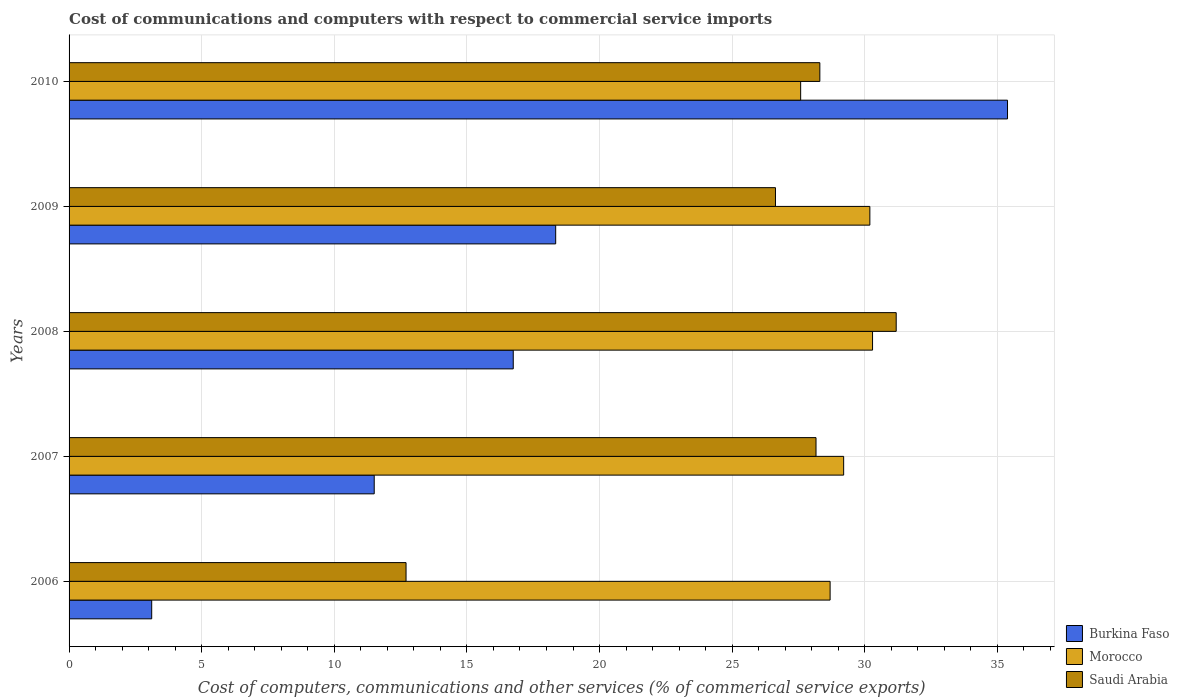How many different coloured bars are there?
Give a very brief answer. 3. Are the number of bars per tick equal to the number of legend labels?
Your answer should be compact. Yes. How many bars are there on the 5th tick from the bottom?
Offer a very short reply. 3. What is the cost of communications and computers in Saudi Arabia in 2008?
Give a very brief answer. 31.19. Across all years, what is the maximum cost of communications and computers in Saudi Arabia?
Ensure brevity in your answer.  31.19. Across all years, what is the minimum cost of communications and computers in Saudi Arabia?
Your response must be concise. 12.71. What is the total cost of communications and computers in Burkina Faso in the graph?
Your answer should be compact. 85.1. What is the difference between the cost of communications and computers in Saudi Arabia in 2009 and that in 2010?
Offer a very short reply. -1.67. What is the difference between the cost of communications and computers in Burkina Faso in 2009 and the cost of communications and computers in Morocco in 2008?
Provide a short and direct response. -11.95. What is the average cost of communications and computers in Morocco per year?
Offer a terse response. 29.19. In the year 2009, what is the difference between the cost of communications and computers in Saudi Arabia and cost of communications and computers in Morocco?
Provide a succinct answer. -3.56. In how many years, is the cost of communications and computers in Saudi Arabia greater than 15 %?
Give a very brief answer. 4. What is the ratio of the cost of communications and computers in Saudi Arabia in 2008 to that in 2009?
Your response must be concise. 1.17. Is the cost of communications and computers in Saudi Arabia in 2007 less than that in 2008?
Provide a succinct answer. Yes. What is the difference between the highest and the second highest cost of communications and computers in Saudi Arabia?
Give a very brief answer. 2.88. What is the difference between the highest and the lowest cost of communications and computers in Saudi Arabia?
Your response must be concise. 18.48. In how many years, is the cost of communications and computers in Morocco greater than the average cost of communications and computers in Morocco taken over all years?
Your answer should be compact. 3. Is the sum of the cost of communications and computers in Saudi Arabia in 2006 and 2007 greater than the maximum cost of communications and computers in Burkina Faso across all years?
Provide a short and direct response. Yes. What does the 2nd bar from the top in 2006 represents?
Keep it short and to the point. Morocco. What does the 2nd bar from the bottom in 2007 represents?
Provide a short and direct response. Morocco. Is it the case that in every year, the sum of the cost of communications and computers in Saudi Arabia and cost of communications and computers in Burkina Faso is greater than the cost of communications and computers in Morocco?
Provide a succinct answer. No. How many bars are there?
Your response must be concise. 15. What is the difference between two consecutive major ticks on the X-axis?
Your answer should be compact. 5. Are the values on the major ticks of X-axis written in scientific E-notation?
Provide a succinct answer. No. Does the graph contain any zero values?
Offer a very short reply. No. Does the graph contain grids?
Keep it short and to the point. Yes. Where does the legend appear in the graph?
Offer a terse response. Bottom right. What is the title of the graph?
Keep it short and to the point. Cost of communications and computers with respect to commercial service imports. What is the label or title of the X-axis?
Provide a succinct answer. Cost of computers, communications and other services (% of commerical service exports). What is the Cost of computers, communications and other services (% of commerical service exports) in Burkina Faso in 2006?
Keep it short and to the point. 3.12. What is the Cost of computers, communications and other services (% of commerical service exports) in Morocco in 2006?
Your response must be concise. 28.69. What is the Cost of computers, communications and other services (% of commerical service exports) of Saudi Arabia in 2006?
Ensure brevity in your answer.  12.71. What is the Cost of computers, communications and other services (% of commerical service exports) in Burkina Faso in 2007?
Your response must be concise. 11.51. What is the Cost of computers, communications and other services (% of commerical service exports) of Morocco in 2007?
Offer a terse response. 29.2. What is the Cost of computers, communications and other services (% of commerical service exports) of Saudi Arabia in 2007?
Give a very brief answer. 28.16. What is the Cost of computers, communications and other services (% of commerical service exports) of Burkina Faso in 2008?
Your answer should be very brief. 16.75. What is the Cost of computers, communications and other services (% of commerical service exports) of Morocco in 2008?
Offer a terse response. 30.29. What is the Cost of computers, communications and other services (% of commerical service exports) in Saudi Arabia in 2008?
Make the answer very short. 31.19. What is the Cost of computers, communications and other services (% of commerical service exports) in Burkina Faso in 2009?
Your answer should be very brief. 18.35. What is the Cost of computers, communications and other services (% of commerical service exports) in Morocco in 2009?
Offer a very short reply. 30.19. What is the Cost of computers, communications and other services (% of commerical service exports) of Saudi Arabia in 2009?
Offer a terse response. 26.63. What is the Cost of computers, communications and other services (% of commerical service exports) in Burkina Faso in 2010?
Your response must be concise. 35.38. What is the Cost of computers, communications and other services (% of commerical service exports) in Morocco in 2010?
Your response must be concise. 27.58. What is the Cost of computers, communications and other services (% of commerical service exports) of Saudi Arabia in 2010?
Your response must be concise. 28.31. Across all years, what is the maximum Cost of computers, communications and other services (% of commerical service exports) in Burkina Faso?
Ensure brevity in your answer.  35.38. Across all years, what is the maximum Cost of computers, communications and other services (% of commerical service exports) of Morocco?
Your answer should be compact. 30.29. Across all years, what is the maximum Cost of computers, communications and other services (% of commerical service exports) of Saudi Arabia?
Keep it short and to the point. 31.19. Across all years, what is the minimum Cost of computers, communications and other services (% of commerical service exports) in Burkina Faso?
Your answer should be compact. 3.12. Across all years, what is the minimum Cost of computers, communications and other services (% of commerical service exports) of Morocco?
Your response must be concise. 27.58. Across all years, what is the minimum Cost of computers, communications and other services (% of commerical service exports) of Saudi Arabia?
Your response must be concise. 12.71. What is the total Cost of computers, communications and other services (% of commerical service exports) in Burkina Faso in the graph?
Keep it short and to the point. 85.1. What is the total Cost of computers, communications and other services (% of commerical service exports) in Morocco in the graph?
Give a very brief answer. 145.97. What is the total Cost of computers, communications and other services (% of commerical service exports) in Saudi Arabia in the graph?
Your response must be concise. 126.99. What is the difference between the Cost of computers, communications and other services (% of commerical service exports) of Burkina Faso in 2006 and that in 2007?
Provide a succinct answer. -8.39. What is the difference between the Cost of computers, communications and other services (% of commerical service exports) in Morocco in 2006 and that in 2007?
Keep it short and to the point. -0.51. What is the difference between the Cost of computers, communications and other services (% of commerical service exports) in Saudi Arabia in 2006 and that in 2007?
Make the answer very short. -15.46. What is the difference between the Cost of computers, communications and other services (% of commerical service exports) in Burkina Faso in 2006 and that in 2008?
Your response must be concise. -13.63. What is the difference between the Cost of computers, communications and other services (% of commerical service exports) of Morocco in 2006 and that in 2008?
Offer a very short reply. -1.6. What is the difference between the Cost of computers, communications and other services (% of commerical service exports) in Saudi Arabia in 2006 and that in 2008?
Your response must be concise. -18.48. What is the difference between the Cost of computers, communications and other services (% of commerical service exports) of Burkina Faso in 2006 and that in 2009?
Give a very brief answer. -15.23. What is the difference between the Cost of computers, communications and other services (% of commerical service exports) of Morocco in 2006 and that in 2009?
Provide a succinct answer. -1.5. What is the difference between the Cost of computers, communications and other services (% of commerical service exports) of Saudi Arabia in 2006 and that in 2009?
Give a very brief answer. -13.93. What is the difference between the Cost of computers, communications and other services (% of commerical service exports) of Burkina Faso in 2006 and that in 2010?
Provide a short and direct response. -32.27. What is the difference between the Cost of computers, communications and other services (% of commerical service exports) in Morocco in 2006 and that in 2010?
Offer a very short reply. 1.11. What is the difference between the Cost of computers, communications and other services (% of commerical service exports) in Saudi Arabia in 2006 and that in 2010?
Your answer should be compact. -15.6. What is the difference between the Cost of computers, communications and other services (% of commerical service exports) in Burkina Faso in 2007 and that in 2008?
Provide a succinct answer. -5.24. What is the difference between the Cost of computers, communications and other services (% of commerical service exports) of Morocco in 2007 and that in 2008?
Provide a short and direct response. -1.09. What is the difference between the Cost of computers, communications and other services (% of commerical service exports) of Saudi Arabia in 2007 and that in 2008?
Provide a succinct answer. -3.02. What is the difference between the Cost of computers, communications and other services (% of commerical service exports) in Burkina Faso in 2007 and that in 2009?
Your answer should be compact. -6.84. What is the difference between the Cost of computers, communications and other services (% of commerical service exports) in Morocco in 2007 and that in 2009?
Your response must be concise. -0.99. What is the difference between the Cost of computers, communications and other services (% of commerical service exports) in Saudi Arabia in 2007 and that in 2009?
Provide a short and direct response. 1.53. What is the difference between the Cost of computers, communications and other services (% of commerical service exports) of Burkina Faso in 2007 and that in 2010?
Your answer should be compact. -23.88. What is the difference between the Cost of computers, communications and other services (% of commerical service exports) in Morocco in 2007 and that in 2010?
Offer a very short reply. 1.62. What is the difference between the Cost of computers, communications and other services (% of commerical service exports) of Saudi Arabia in 2007 and that in 2010?
Keep it short and to the point. -0.14. What is the difference between the Cost of computers, communications and other services (% of commerical service exports) in Burkina Faso in 2008 and that in 2009?
Provide a short and direct response. -1.6. What is the difference between the Cost of computers, communications and other services (% of commerical service exports) of Morocco in 2008 and that in 2009?
Offer a terse response. 0.1. What is the difference between the Cost of computers, communications and other services (% of commerical service exports) of Saudi Arabia in 2008 and that in 2009?
Offer a terse response. 4.55. What is the difference between the Cost of computers, communications and other services (% of commerical service exports) in Burkina Faso in 2008 and that in 2010?
Give a very brief answer. -18.64. What is the difference between the Cost of computers, communications and other services (% of commerical service exports) of Morocco in 2008 and that in 2010?
Your answer should be compact. 2.71. What is the difference between the Cost of computers, communications and other services (% of commerical service exports) of Saudi Arabia in 2008 and that in 2010?
Your answer should be very brief. 2.88. What is the difference between the Cost of computers, communications and other services (% of commerical service exports) in Burkina Faso in 2009 and that in 2010?
Provide a short and direct response. -17.04. What is the difference between the Cost of computers, communications and other services (% of commerical service exports) in Morocco in 2009 and that in 2010?
Your answer should be compact. 2.61. What is the difference between the Cost of computers, communications and other services (% of commerical service exports) of Saudi Arabia in 2009 and that in 2010?
Make the answer very short. -1.67. What is the difference between the Cost of computers, communications and other services (% of commerical service exports) of Burkina Faso in 2006 and the Cost of computers, communications and other services (% of commerical service exports) of Morocco in 2007?
Provide a short and direct response. -26.09. What is the difference between the Cost of computers, communications and other services (% of commerical service exports) in Burkina Faso in 2006 and the Cost of computers, communications and other services (% of commerical service exports) in Saudi Arabia in 2007?
Keep it short and to the point. -25.05. What is the difference between the Cost of computers, communications and other services (% of commerical service exports) of Morocco in 2006 and the Cost of computers, communications and other services (% of commerical service exports) of Saudi Arabia in 2007?
Your response must be concise. 0.53. What is the difference between the Cost of computers, communications and other services (% of commerical service exports) in Burkina Faso in 2006 and the Cost of computers, communications and other services (% of commerical service exports) in Morocco in 2008?
Provide a succinct answer. -27.18. What is the difference between the Cost of computers, communications and other services (% of commerical service exports) in Burkina Faso in 2006 and the Cost of computers, communications and other services (% of commerical service exports) in Saudi Arabia in 2008?
Make the answer very short. -28.07. What is the difference between the Cost of computers, communications and other services (% of commerical service exports) of Morocco in 2006 and the Cost of computers, communications and other services (% of commerical service exports) of Saudi Arabia in 2008?
Provide a short and direct response. -2.49. What is the difference between the Cost of computers, communications and other services (% of commerical service exports) in Burkina Faso in 2006 and the Cost of computers, communications and other services (% of commerical service exports) in Morocco in 2009?
Provide a succinct answer. -27.08. What is the difference between the Cost of computers, communications and other services (% of commerical service exports) in Burkina Faso in 2006 and the Cost of computers, communications and other services (% of commerical service exports) in Saudi Arabia in 2009?
Give a very brief answer. -23.52. What is the difference between the Cost of computers, communications and other services (% of commerical service exports) in Morocco in 2006 and the Cost of computers, communications and other services (% of commerical service exports) in Saudi Arabia in 2009?
Provide a succinct answer. 2.06. What is the difference between the Cost of computers, communications and other services (% of commerical service exports) in Burkina Faso in 2006 and the Cost of computers, communications and other services (% of commerical service exports) in Morocco in 2010?
Offer a terse response. -24.47. What is the difference between the Cost of computers, communications and other services (% of commerical service exports) of Burkina Faso in 2006 and the Cost of computers, communications and other services (% of commerical service exports) of Saudi Arabia in 2010?
Your response must be concise. -25.19. What is the difference between the Cost of computers, communications and other services (% of commerical service exports) in Morocco in 2006 and the Cost of computers, communications and other services (% of commerical service exports) in Saudi Arabia in 2010?
Provide a short and direct response. 0.39. What is the difference between the Cost of computers, communications and other services (% of commerical service exports) in Burkina Faso in 2007 and the Cost of computers, communications and other services (% of commerical service exports) in Morocco in 2008?
Give a very brief answer. -18.79. What is the difference between the Cost of computers, communications and other services (% of commerical service exports) in Burkina Faso in 2007 and the Cost of computers, communications and other services (% of commerical service exports) in Saudi Arabia in 2008?
Your answer should be very brief. -19.68. What is the difference between the Cost of computers, communications and other services (% of commerical service exports) in Morocco in 2007 and the Cost of computers, communications and other services (% of commerical service exports) in Saudi Arabia in 2008?
Provide a short and direct response. -1.98. What is the difference between the Cost of computers, communications and other services (% of commerical service exports) in Burkina Faso in 2007 and the Cost of computers, communications and other services (% of commerical service exports) in Morocco in 2009?
Your response must be concise. -18.69. What is the difference between the Cost of computers, communications and other services (% of commerical service exports) in Burkina Faso in 2007 and the Cost of computers, communications and other services (% of commerical service exports) in Saudi Arabia in 2009?
Your answer should be very brief. -15.13. What is the difference between the Cost of computers, communications and other services (% of commerical service exports) in Morocco in 2007 and the Cost of computers, communications and other services (% of commerical service exports) in Saudi Arabia in 2009?
Provide a succinct answer. 2.57. What is the difference between the Cost of computers, communications and other services (% of commerical service exports) in Burkina Faso in 2007 and the Cost of computers, communications and other services (% of commerical service exports) in Morocco in 2010?
Keep it short and to the point. -16.08. What is the difference between the Cost of computers, communications and other services (% of commerical service exports) in Burkina Faso in 2007 and the Cost of computers, communications and other services (% of commerical service exports) in Saudi Arabia in 2010?
Offer a very short reply. -16.8. What is the difference between the Cost of computers, communications and other services (% of commerical service exports) of Morocco in 2007 and the Cost of computers, communications and other services (% of commerical service exports) of Saudi Arabia in 2010?
Your response must be concise. 0.9. What is the difference between the Cost of computers, communications and other services (% of commerical service exports) of Burkina Faso in 2008 and the Cost of computers, communications and other services (% of commerical service exports) of Morocco in 2009?
Give a very brief answer. -13.45. What is the difference between the Cost of computers, communications and other services (% of commerical service exports) of Burkina Faso in 2008 and the Cost of computers, communications and other services (% of commerical service exports) of Saudi Arabia in 2009?
Offer a very short reply. -9.89. What is the difference between the Cost of computers, communications and other services (% of commerical service exports) in Morocco in 2008 and the Cost of computers, communications and other services (% of commerical service exports) in Saudi Arabia in 2009?
Provide a succinct answer. 3.66. What is the difference between the Cost of computers, communications and other services (% of commerical service exports) of Burkina Faso in 2008 and the Cost of computers, communications and other services (% of commerical service exports) of Morocco in 2010?
Offer a terse response. -10.84. What is the difference between the Cost of computers, communications and other services (% of commerical service exports) in Burkina Faso in 2008 and the Cost of computers, communications and other services (% of commerical service exports) in Saudi Arabia in 2010?
Your response must be concise. -11.56. What is the difference between the Cost of computers, communications and other services (% of commerical service exports) in Morocco in 2008 and the Cost of computers, communications and other services (% of commerical service exports) in Saudi Arabia in 2010?
Your answer should be compact. 1.99. What is the difference between the Cost of computers, communications and other services (% of commerical service exports) in Burkina Faso in 2009 and the Cost of computers, communications and other services (% of commerical service exports) in Morocco in 2010?
Offer a very short reply. -9.24. What is the difference between the Cost of computers, communications and other services (% of commerical service exports) in Burkina Faso in 2009 and the Cost of computers, communications and other services (% of commerical service exports) in Saudi Arabia in 2010?
Your answer should be compact. -9.96. What is the difference between the Cost of computers, communications and other services (% of commerical service exports) in Morocco in 2009 and the Cost of computers, communications and other services (% of commerical service exports) in Saudi Arabia in 2010?
Give a very brief answer. 1.89. What is the average Cost of computers, communications and other services (% of commerical service exports) in Burkina Faso per year?
Offer a terse response. 17.02. What is the average Cost of computers, communications and other services (% of commerical service exports) of Morocco per year?
Provide a short and direct response. 29.19. What is the average Cost of computers, communications and other services (% of commerical service exports) of Saudi Arabia per year?
Keep it short and to the point. 25.4. In the year 2006, what is the difference between the Cost of computers, communications and other services (% of commerical service exports) of Burkina Faso and Cost of computers, communications and other services (% of commerical service exports) of Morocco?
Ensure brevity in your answer.  -25.58. In the year 2006, what is the difference between the Cost of computers, communications and other services (% of commerical service exports) of Burkina Faso and Cost of computers, communications and other services (% of commerical service exports) of Saudi Arabia?
Provide a succinct answer. -9.59. In the year 2006, what is the difference between the Cost of computers, communications and other services (% of commerical service exports) of Morocco and Cost of computers, communications and other services (% of commerical service exports) of Saudi Arabia?
Offer a very short reply. 15.99. In the year 2007, what is the difference between the Cost of computers, communications and other services (% of commerical service exports) in Burkina Faso and Cost of computers, communications and other services (% of commerical service exports) in Morocco?
Ensure brevity in your answer.  -17.7. In the year 2007, what is the difference between the Cost of computers, communications and other services (% of commerical service exports) in Burkina Faso and Cost of computers, communications and other services (% of commerical service exports) in Saudi Arabia?
Provide a succinct answer. -16.66. In the year 2007, what is the difference between the Cost of computers, communications and other services (% of commerical service exports) in Morocco and Cost of computers, communications and other services (% of commerical service exports) in Saudi Arabia?
Your response must be concise. 1.04. In the year 2008, what is the difference between the Cost of computers, communications and other services (% of commerical service exports) in Burkina Faso and Cost of computers, communications and other services (% of commerical service exports) in Morocco?
Offer a very short reply. -13.55. In the year 2008, what is the difference between the Cost of computers, communications and other services (% of commerical service exports) in Burkina Faso and Cost of computers, communications and other services (% of commerical service exports) in Saudi Arabia?
Your answer should be very brief. -14.44. In the year 2008, what is the difference between the Cost of computers, communications and other services (% of commerical service exports) in Morocco and Cost of computers, communications and other services (% of commerical service exports) in Saudi Arabia?
Ensure brevity in your answer.  -0.89. In the year 2009, what is the difference between the Cost of computers, communications and other services (% of commerical service exports) in Burkina Faso and Cost of computers, communications and other services (% of commerical service exports) in Morocco?
Make the answer very short. -11.85. In the year 2009, what is the difference between the Cost of computers, communications and other services (% of commerical service exports) in Burkina Faso and Cost of computers, communications and other services (% of commerical service exports) in Saudi Arabia?
Provide a succinct answer. -8.29. In the year 2009, what is the difference between the Cost of computers, communications and other services (% of commerical service exports) in Morocco and Cost of computers, communications and other services (% of commerical service exports) in Saudi Arabia?
Keep it short and to the point. 3.56. In the year 2010, what is the difference between the Cost of computers, communications and other services (% of commerical service exports) in Burkina Faso and Cost of computers, communications and other services (% of commerical service exports) in Morocco?
Your response must be concise. 7.8. In the year 2010, what is the difference between the Cost of computers, communications and other services (% of commerical service exports) in Burkina Faso and Cost of computers, communications and other services (% of commerical service exports) in Saudi Arabia?
Offer a terse response. 7.08. In the year 2010, what is the difference between the Cost of computers, communications and other services (% of commerical service exports) in Morocco and Cost of computers, communications and other services (% of commerical service exports) in Saudi Arabia?
Keep it short and to the point. -0.72. What is the ratio of the Cost of computers, communications and other services (% of commerical service exports) of Burkina Faso in 2006 to that in 2007?
Ensure brevity in your answer.  0.27. What is the ratio of the Cost of computers, communications and other services (% of commerical service exports) in Morocco in 2006 to that in 2007?
Keep it short and to the point. 0.98. What is the ratio of the Cost of computers, communications and other services (% of commerical service exports) in Saudi Arabia in 2006 to that in 2007?
Your answer should be very brief. 0.45. What is the ratio of the Cost of computers, communications and other services (% of commerical service exports) in Burkina Faso in 2006 to that in 2008?
Give a very brief answer. 0.19. What is the ratio of the Cost of computers, communications and other services (% of commerical service exports) in Morocco in 2006 to that in 2008?
Your answer should be compact. 0.95. What is the ratio of the Cost of computers, communications and other services (% of commerical service exports) in Saudi Arabia in 2006 to that in 2008?
Offer a very short reply. 0.41. What is the ratio of the Cost of computers, communications and other services (% of commerical service exports) in Burkina Faso in 2006 to that in 2009?
Provide a short and direct response. 0.17. What is the ratio of the Cost of computers, communications and other services (% of commerical service exports) of Morocco in 2006 to that in 2009?
Give a very brief answer. 0.95. What is the ratio of the Cost of computers, communications and other services (% of commerical service exports) of Saudi Arabia in 2006 to that in 2009?
Provide a short and direct response. 0.48. What is the ratio of the Cost of computers, communications and other services (% of commerical service exports) of Burkina Faso in 2006 to that in 2010?
Keep it short and to the point. 0.09. What is the ratio of the Cost of computers, communications and other services (% of commerical service exports) in Morocco in 2006 to that in 2010?
Keep it short and to the point. 1.04. What is the ratio of the Cost of computers, communications and other services (% of commerical service exports) of Saudi Arabia in 2006 to that in 2010?
Make the answer very short. 0.45. What is the ratio of the Cost of computers, communications and other services (% of commerical service exports) in Burkina Faso in 2007 to that in 2008?
Give a very brief answer. 0.69. What is the ratio of the Cost of computers, communications and other services (% of commerical service exports) in Saudi Arabia in 2007 to that in 2008?
Keep it short and to the point. 0.9. What is the ratio of the Cost of computers, communications and other services (% of commerical service exports) in Burkina Faso in 2007 to that in 2009?
Keep it short and to the point. 0.63. What is the ratio of the Cost of computers, communications and other services (% of commerical service exports) in Morocco in 2007 to that in 2009?
Your answer should be very brief. 0.97. What is the ratio of the Cost of computers, communications and other services (% of commerical service exports) in Saudi Arabia in 2007 to that in 2009?
Offer a terse response. 1.06. What is the ratio of the Cost of computers, communications and other services (% of commerical service exports) in Burkina Faso in 2007 to that in 2010?
Provide a succinct answer. 0.33. What is the ratio of the Cost of computers, communications and other services (% of commerical service exports) in Morocco in 2007 to that in 2010?
Give a very brief answer. 1.06. What is the ratio of the Cost of computers, communications and other services (% of commerical service exports) in Saudi Arabia in 2007 to that in 2010?
Provide a succinct answer. 0.99. What is the ratio of the Cost of computers, communications and other services (% of commerical service exports) of Burkina Faso in 2008 to that in 2009?
Provide a short and direct response. 0.91. What is the ratio of the Cost of computers, communications and other services (% of commerical service exports) in Saudi Arabia in 2008 to that in 2009?
Provide a succinct answer. 1.17. What is the ratio of the Cost of computers, communications and other services (% of commerical service exports) of Burkina Faso in 2008 to that in 2010?
Provide a succinct answer. 0.47. What is the ratio of the Cost of computers, communications and other services (% of commerical service exports) in Morocco in 2008 to that in 2010?
Offer a very short reply. 1.1. What is the ratio of the Cost of computers, communications and other services (% of commerical service exports) of Saudi Arabia in 2008 to that in 2010?
Make the answer very short. 1.1. What is the ratio of the Cost of computers, communications and other services (% of commerical service exports) of Burkina Faso in 2009 to that in 2010?
Your answer should be very brief. 0.52. What is the ratio of the Cost of computers, communications and other services (% of commerical service exports) of Morocco in 2009 to that in 2010?
Offer a very short reply. 1.09. What is the ratio of the Cost of computers, communications and other services (% of commerical service exports) of Saudi Arabia in 2009 to that in 2010?
Offer a very short reply. 0.94. What is the difference between the highest and the second highest Cost of computers, communications and other services (% of commerical service exports) in Burkina Faso?
Your response must be concise. 17.04. What is the difference between the highest and the second highest Cost of computers, communications and other services (% of commerical service exports) of Morocco?
Your response must be concise. 0.1. What is the difference between the highest and the second highest Cost of computers, communications and other services (% of commerical service exports) of Saudi Arabia?
Ensure brevity in your answer.  2.88. What is the difference between the highest and the lowest Cost of computers, communications and other services (% of commerical service exports) in Burkina Faso?
Your response must be concise. 32.27. What is the difference between the highest and the lowest Cost of computers, communications and other services (% of commerical service exports) of Morocco?
Offer a terse response. 2.71. What is the difference between the highest and the lowest Cost of computers, communications and other services (% of commerical service exports) in Saudi Arabia?
Ensure brevity in your answer.  18.48. 